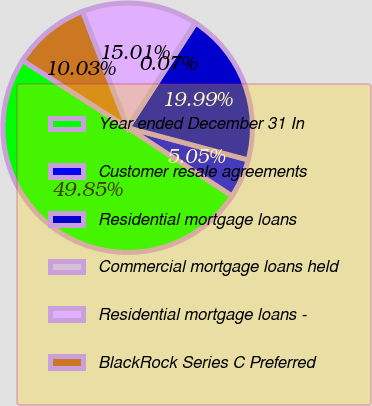Convert chart to OTSL. <chart><loc_0><loc_0><loc_500><loc_500><pie_chart><fcel>Year ended December 31 In<fcel>Customer resale agreements<fcel>Residential mortgage loans<fcel>Commercial mortgage loans held<fcel>Residential mortgage loans -<fcel>BlackRock Series C Preferred<nl><fcel>49.85%<fcel>5.05%<fcel>19.99%<fcel>0.07%<fcel>15.01%<fcel>10.03%<nl></chart> 